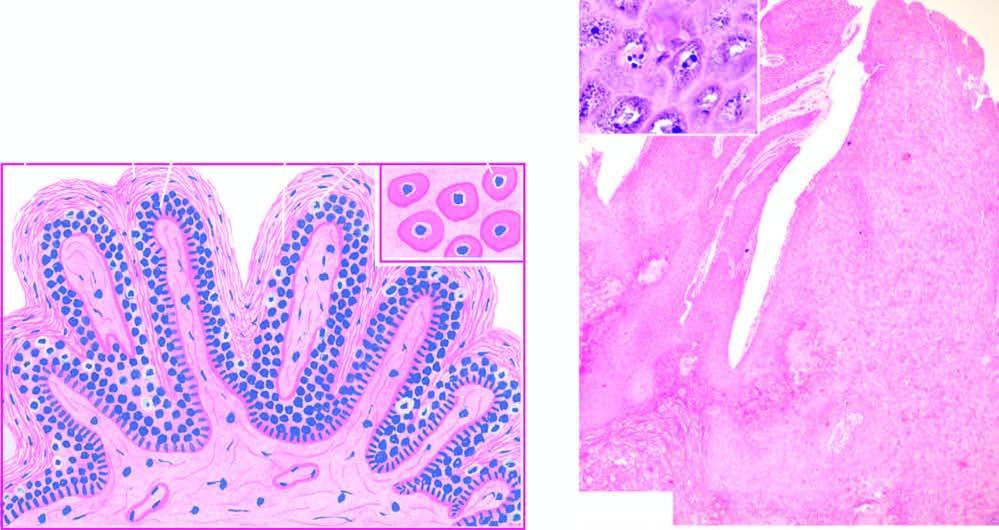re microscopic features found in the upper stratum malpighii?
Answer the question using a single word or phrase. No 